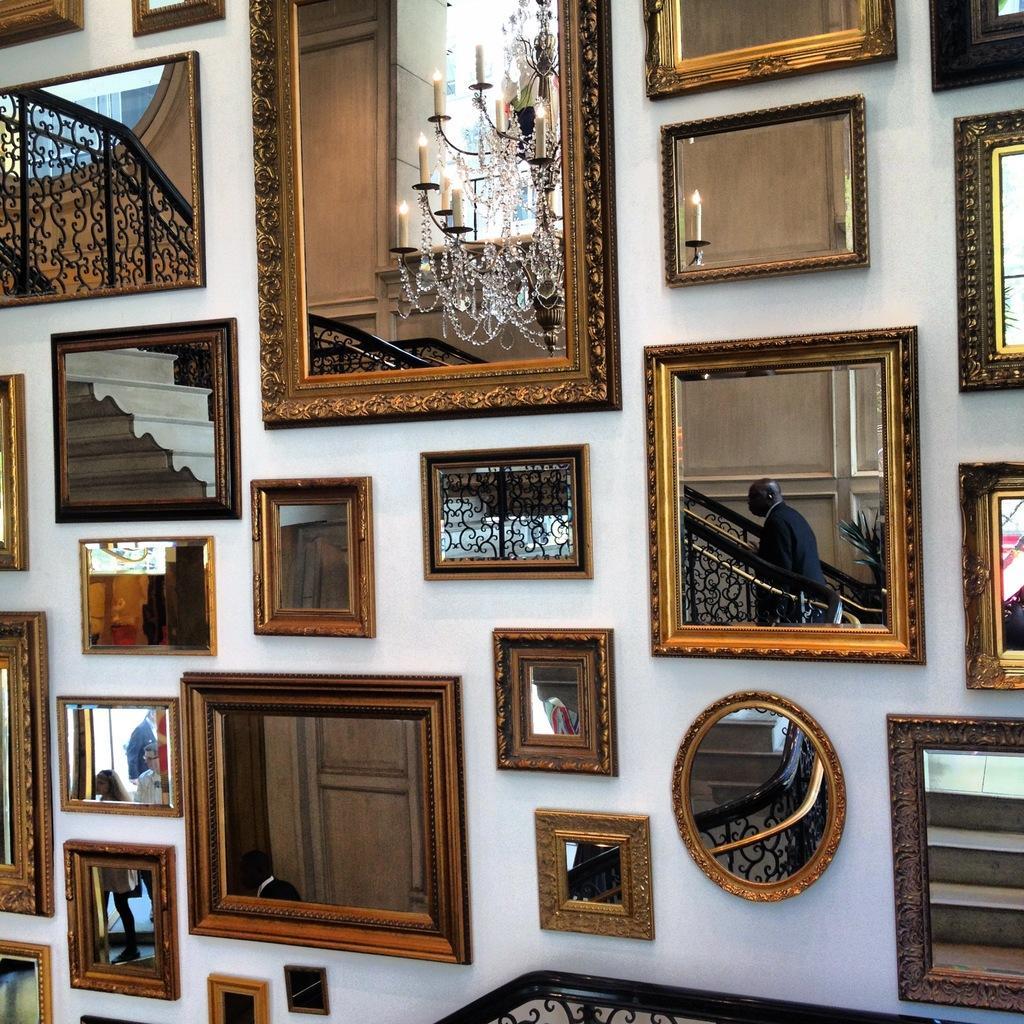Could you give a brief overview of what you see in this image? In this picture I can see there is a wall and there are some mirrors on the wall and I can see there are some stairs here and there are lights attached to the ceiling and there is a person climbing the stairs. 